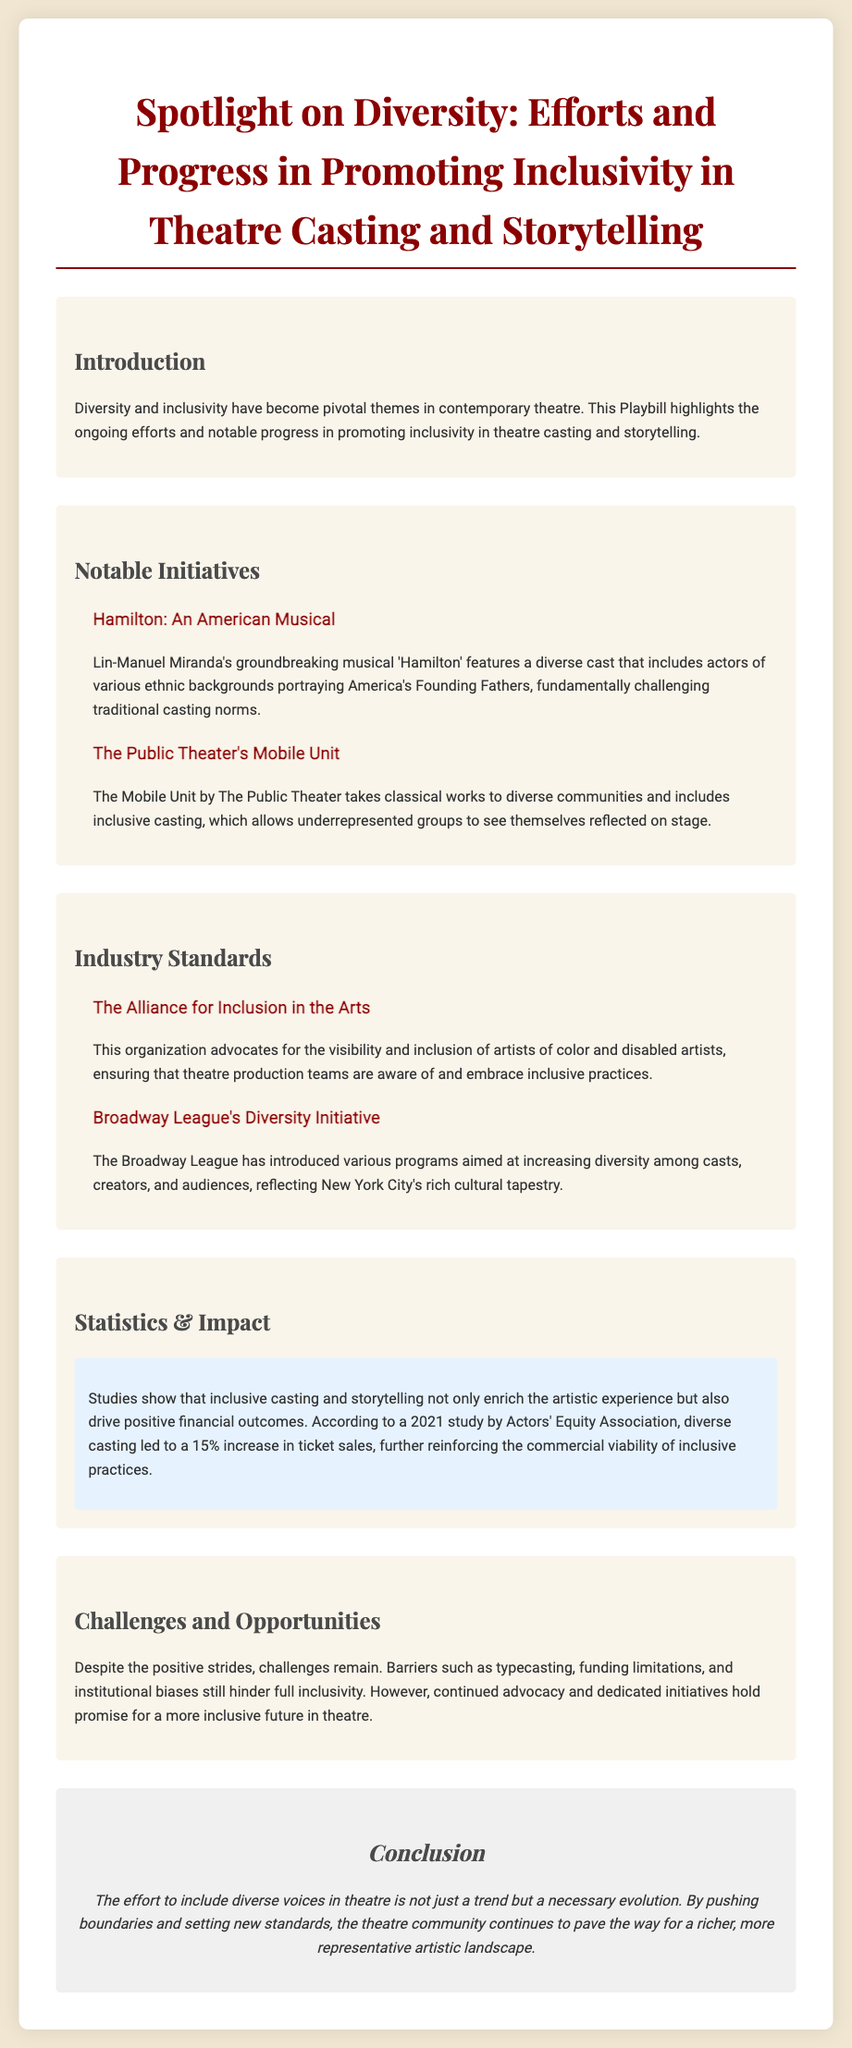What is the main theme of the Playbill? The main theme of the Playbill revolves around the ongoing efforts and notable progress in promoting inclusivity in theatre casting and storytelling.
Answer: Inclusivity Who is the creator of 'Hamilton'? Lin-Manuel Miranda is identified as the creator of the groundbreaking musical 'Hamilton' featured in the document.
Answer: Lin-Manuel Miranda Which organization advocates for artists of color and disabled artists? The Alliance for Inclusion in the Arts is mentioned as the organization advocating for visibility and inclusion of these artists.
Answer: The Alliance for Inclusion in the Arts What percentage increase in ticket sales was reported from diverse casting? The document states a 15% increase in ticket sales due to diverse casting, as per a 2021 study.
Answer: 15% What is a challenge mentioned in achieving inclusivity in theatre? The document lists typecasting, funding limitations, and institutional biases as challenges to achieving full inclusivity.
Answer: Typecasting What is the title of the initiative by the Broadway League? The Playbill mentions the Broadway League's Diversity Initiative focusing on increasing diversity among casts and creators.
Answer: Diversity Initiative What type of works does The Public Theater's Mobile Unit focus on? The Mobile Unit takes classical works to diverse communities, reflecting its focus on inclusivity in performances.
Answer: Classical works What is the purpose of diverse casting according to the studies mentioned? The studies highlight that inclusive casting not only enriches the artistic experience but also drives positive financial outcomes.
Answer: Financial outcomes 